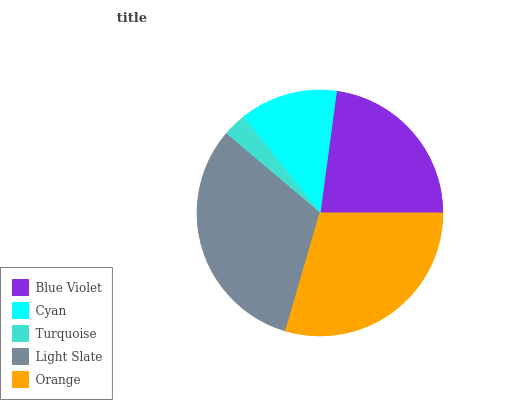Is Turquoise the minimum?
Answer yes or no. Yes. Is Light Slate the maximum?
Answer yes or no. Yes. Is Cyan the minimum?
Answer yes or no. No. Is Cyan the maximum?
Answer yes or no. No. Is Blue Violet greater than Cyan?
Answer yes or no. Yes. Is Cyan less than Blue Violet?
Answer yes or no. Yes. Is Cyan greater than Blue Violet?
Answer yes or no. No. Is Blue Violet less than Cyan?
Answer yes or no. No. Is Blue Violet the high median?
Answer yes or no. Yes. Is Blue Violet the low median?
Answer yes or no. Yes. Is Turquoise the high median?
Answer yes or no. No. Is Cyan the low median?
Answer yes or no. No. 